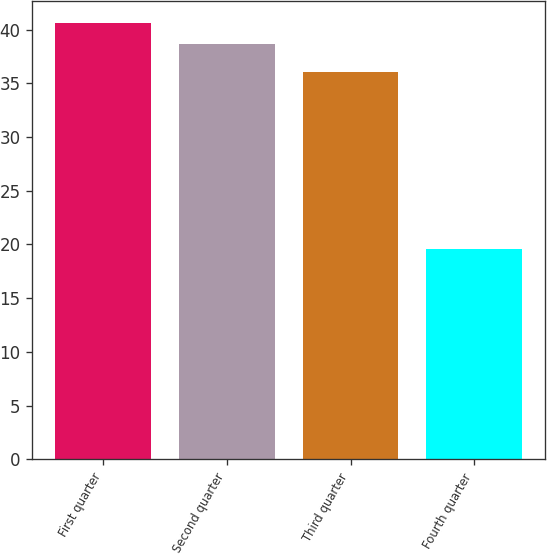Convert chart to OTSL. <chart><loc_0><loc_0><loc_500><loc_500><bar_chart><fcel>First quarter<fcel>Second quarter<fcel>Third quarter<fcel>Fourth quarter<nl><fcel>40.64<fcel>38.62<fcel>36.07<fcel>19.6<nl></chart> 